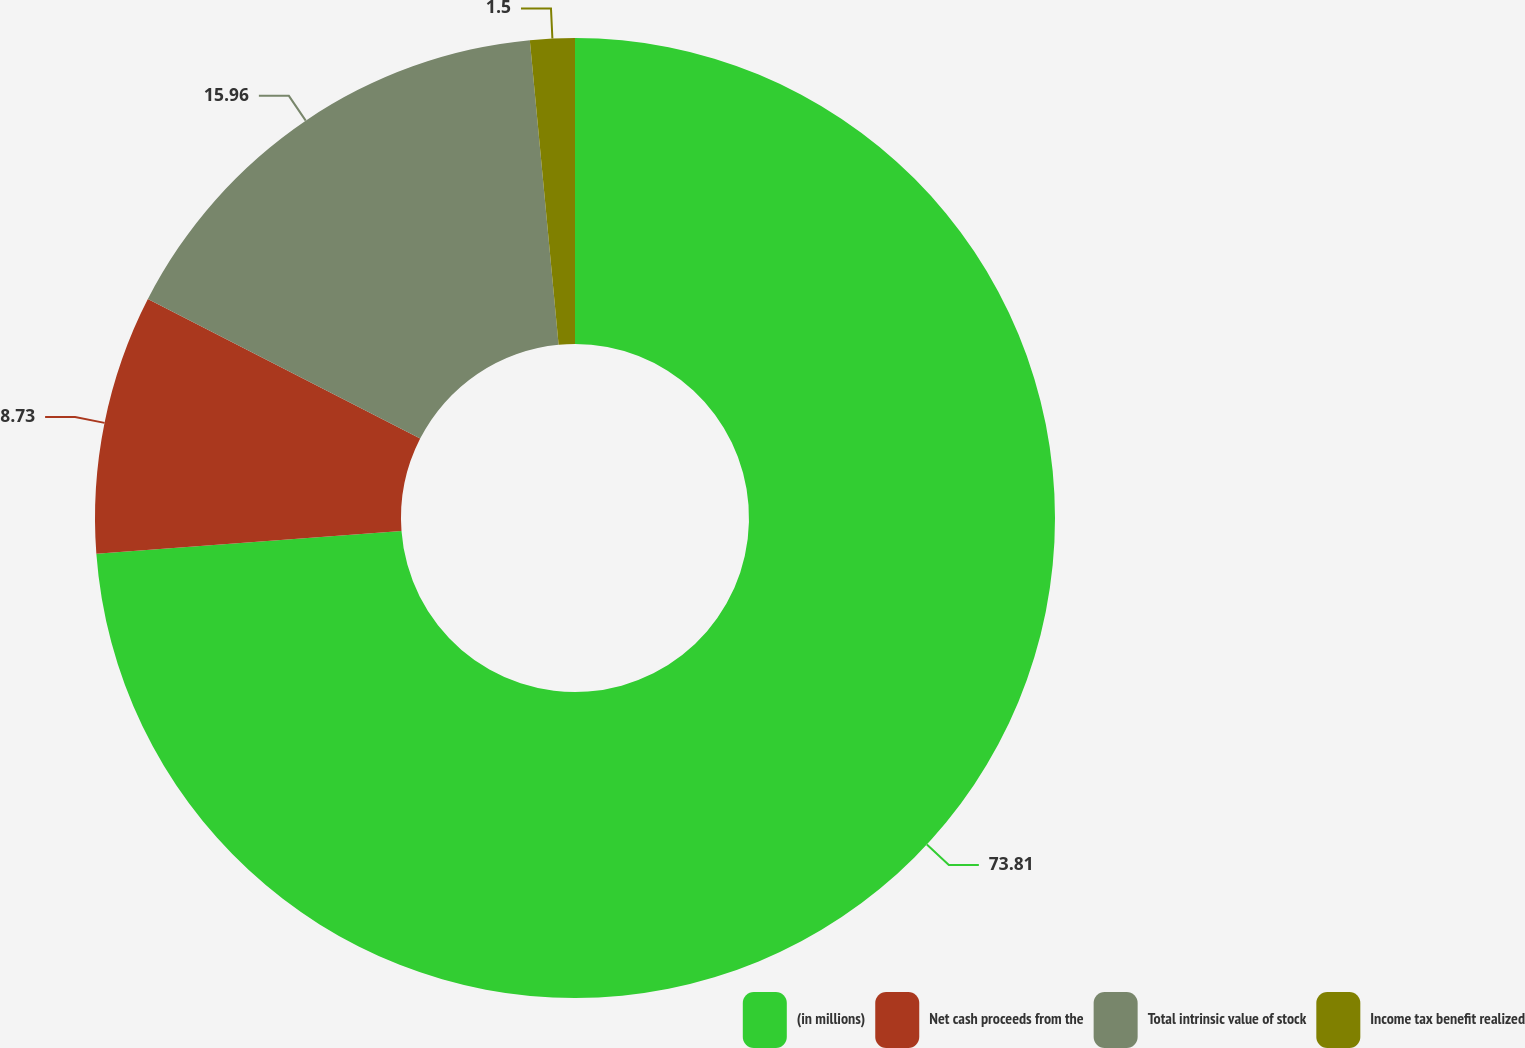Convert chart. <chart><loc_0><loc_0><loc_500><loc_500><pie_chart><fcel>(in millions)<fcel>Net cash proceeds from the<fcel>Total intrinsic value of stock<fcel>Income tax benefit realized<nl><fcel>73.81%<fcel>8.73%<fcel>15.96%<fcel>1.5%<nl></chart> 